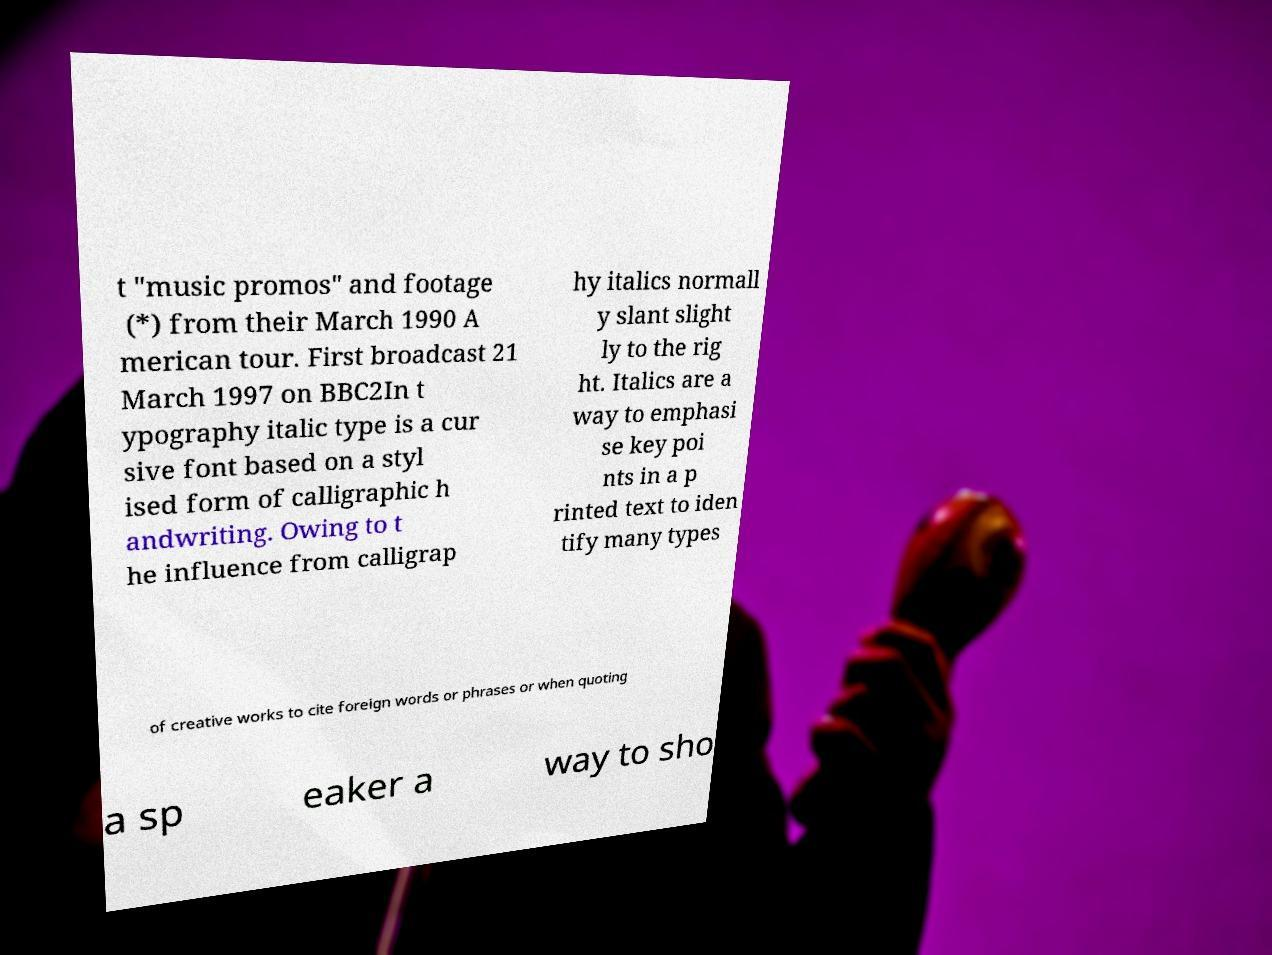Can you read and provide the text displayed in the image?This photo seems to have some interesting text. Can you extract and type it out for me? t "music promos" and footage (*) from their March 1990 A merican tour. First broadcast 21 March 1997 on BBC2In t ypography italic type is a cur sive font based on a styl ised form of calligraphic h andwriting. Owing to t he influence from calligrap hy italics normall y slant slight ly to the rig ht. Italics are a way to emphasi se key poi nts in a p rinted text to iden tify many types of creative works to cite foreign words or phrases or when quoting a sp eaker a way to sho 